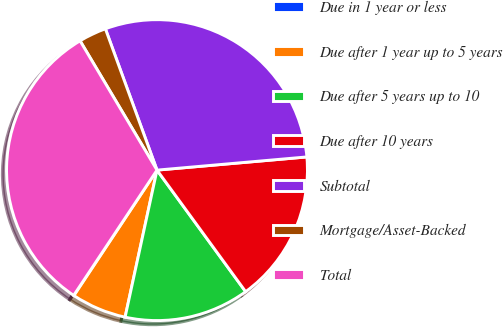Convert chart. <chart><loc_0><loc_0><loc_500><loc_500><pie_chart><fcel>Due in 1 year or less<fcel>Due after 1 year up to 5 years<fcel>Due after 5 years up to 10<fcel>Due after 10 years<fcel>Subtotal<fcel>Mortgage/Asset-Backed<fcel>Total<nl><fcel>0.03%<fcel>5.91%<fcel>13.43%<fcel>16.37%<fcel>29.18%<fcel>2.97%<fcel>32.12%<nl></chart> 